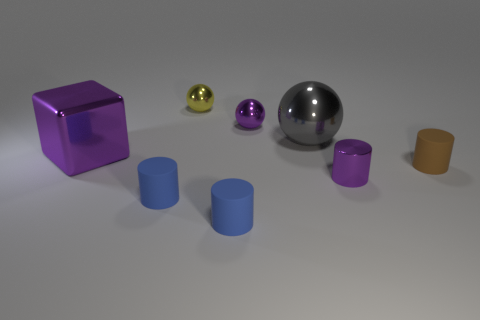There is a yellow thing; does it have the same size as the purple object to the right of the purple metallic sphere?
Ensure brevity in your answer.  Yes. How many matte objects are big purple cubes or big cylinders?
Offer a very short reply. 0. How many gray things have the same shape as the brown rubber object?
Keep it short and to the point. 0. What is the material of the tiny thing that is the same color as the tiny shiny cylinder?
Give a very brief answer. Metal. There is a matte cylinder on the right side of the big gray object; does it have the same size as the purple shiny block that is to the left of the gray shiny sphere?
Provide a short and direct response. No. The blue thing to the right of the yellow thing has what shape?
Offer a terse response. Cylinder. Are there an equal number of small metal cylinders and small brown blocks?
Your response must be concise. No. What is the material of the other large thing that is the same shape as the yellow shiny object?
Provide a short and direct response. Metal. There is a gray metal ball left of the brown rubber thing; is its size the same as the tiny yellow metal ball?
Give a very brief answer. No. How many tiny purple metal cylinders are right of the gray ball?
Your answer should be very brief. 1. 